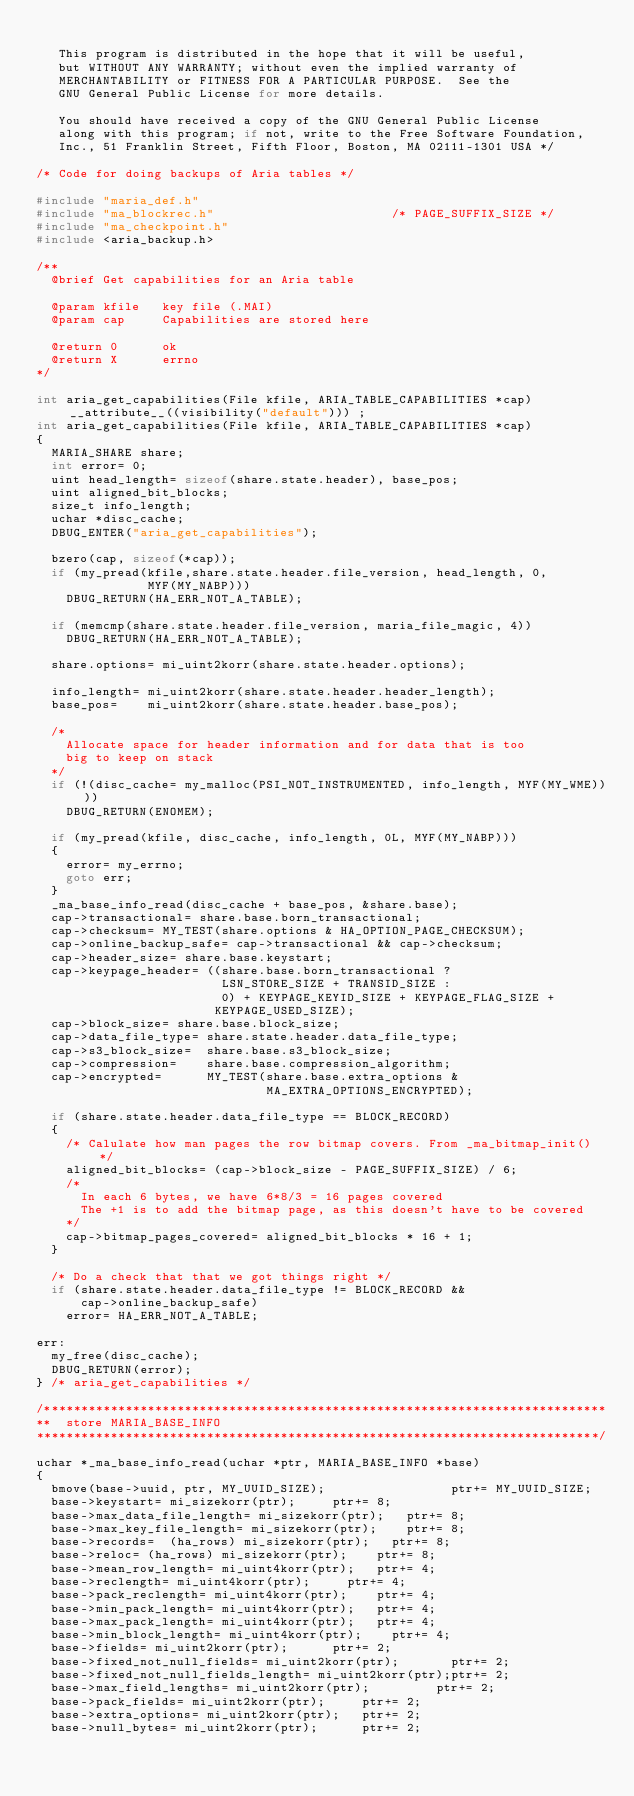Convert code to text. <code><loc_0><loc_0><loc_500><loc_500><_C_>
   This program is distributed in the hope that it will be useful,
   but WITHOUT ANY WARRANTY; without even the implied warranty of
   MERCHANTABILITY or FITNESS FOR A PARTICULAR PURPOSE.  See the
   GNU General Public License for more details.

   You should have received a copy of the GNU General Public License
   along with this program; if not, write to the Free Software Foundation,
   Inc., 51 Franklin Street, Fifth Floor, Boston, MA 02111-1301 USA */

/* Code for doing backups of Aria tables */

#include "maria_def.h"
#include "ma_blockrec.h"                        /* PAGE_SUFFIX_SIZE */
#include "ma_checkpoint.h"
#include <aria_backup.h>

/**
  @brief Get capabilities for an Aria table

  @param kfile   key file (.MAI)
  @param cap     Capabilities are stored here

  @return 0      ok
  @return X      errno
*/

int aria_get_capabilities(File kfile, ARIA_TABLE_CAPABILITIES *cap)__attribute__((visibility("default"))) ;
int aria_get_capabilities(File kfile, ARIA_TABLE_CAPABILITIES *cap)
{
  MARIA_SHARE share;
  int error= 0;
  uint head_length= sizeof(share.state.header), base_pos;
  uint aligned_bit_blocks;
  size_t info_length;
  uchar *disc_cache;
  DBUG_ENTER("aria_get_capabilities");

  bzero(cap, sizeof(*cap));
  if (my_pread(kfile,share.state.header.file_version, head_length, 0,
               MYF(MY_NABP)))
    DBUG_RETURN(HA_ERR_NOT_A_TABLE);

  if (memcmp(share.state.header.file_version, maria_file_magic, 4))
    DBUG_RETURN(HA_ERR_NOT_A_TABLE);

  share.options= mi_uint2korr(share.state.header.options);

  info_length= mi_uint2korr(share.state.header.header_length);
  base_pos=    mi_uint2korr(share.state.header.base_pos);

  /*
    Allocate space for header information and for data that is too
    big to keep on stack
  */
  if (!(disc_cache= my_malloc(PSI_NOT_INSTRUMENTED, info_length, MYF(MY_WME))))
    DBUG_RETURN(ENOMEM);

  if (my_pread(kfile, disc_cache, info_length, 0L, MYF(MY_NABP)))
  {
    error= my_errno;
    goto err;
  }
  _ma_base_info_read(disc_cache + base_pos, &share.base);
  cap->transactional= share.base.born_transactional;
  cap->checksum= MY_TEST(share.options & HA_OPTION_PAGE_CHECKSUM);
  cap->online_backup_safe= cap->transactional && cap->checksum;
  cap->header_size= share.base.keystart;
  cap->keypage_header= ((share.base.born_transactional ?
                         LSN_STORE_SIZE + TRANSID_SIZE :
                         0) + KEYPAGE_KEYID_SIZE + KEYPAGE_FLAG_SIZE +
                        KEYPAGE_USED_SIZE);
  cap->block_size= share.base.block_size;
  cap->data_file_type= share.state.header.data_file_type;
  cap->s3_block_size=  share.base.s3_block_size;
  cap->compression=    share.base.compression_algorithm;
  cap->encrypted=      MY_TEST(share.base.extra_options &
                               MA_EXTRA_OPTIONS_ENCRYPTED);

  if (share.state.header.data_file_type == BLOCK_RECORD)
  {
    /* Calulate how man pages the row bitmap covers. From _ma_bitmap_init() */
    aligned_bit_blocks= (cap->block_size - PAGE_SUFFIX_SIZE) / 6;
    /*
      In each 6 bytes, we have 6*8/3 = 16 pages covered
      The +1 is to add the bitmap page, as this doesn't have to be covered
    */
    cap->bitmap_pages_covered= aligned_bit_blocks * 16 + 1;
  }

  /* Do a check that that we got things right */
  if (share.state.header.data_file_type != BLOCK_RECORD &&
      cap->online_backup_safe)
    error= HA_ERR_NOT_A_TABLE;

err:
  my_free(disc_cache);
  DBUG_RETURN(error);
} /* aria_get_capabilities */

/****************************************************************************
**  store MARIA_BASE_INFO
****************************************************************************/

uchar *_ma_base_info_read(uchar *ptr, MARIA_BASE_INFO *base)
{
  bmove(base->uuid, ptr, MY_UUID_SIZE);                 ptr+= MY_UUID_SIZE;
  base->keystart= mi_sizekorr(ptr);			ptr+= 8;
  base->max_data_file_length= mi_sizekorr(ptr); 	ptr+= 8;
  base->max_key_file_length= mi_sizekorr(ptr);		ptr+= 8;
  base->records=  (ha_rows) mi_sizekorr(ptr);		ptr+= 8;
  base->reloc= (ha_rows) mi_sizekorr(ptr);		ptr+= 8;
  base->mean_row_length= mi_uint4korr(ptr);		ptr+= 4;
  base->reclength= mi_uint4korr(ptr);			ptr+= 4;
  base->pack_reclength= mi_uint4korr(ptr);		ptr+= 4;
  base->min_pack_length= mi_uint4korr(ptr);		ptr+= 4;
  base->max_pack_length= mi_uint4korr(ptr);		ptr+= 4;
  base->min_block_length= mi_uint4korr(ptr);		ptr+= 4;
  base->fields= mi_uint2korr(ptr);			ptr+= 2;
  base->fixed_not_null_fields= mi_uint2korr(ptr);       ptr+= 2;
  base->fixed_not_null_fields_length= mi_uint2korr(ptr);ptr+= 2;
  base->max_field_lengths= mi_uint2korr(ptr);	        ptr+= 2;
  base->pack_fields= mi_uint2korr(ptr);			ptr+= 2;
  base->extra_options= mi_uint2korr(ptr);		ptr+= 2;
  base->null_bytes= mi_uint2korr(ptr);			ptr+= 2;</code> 